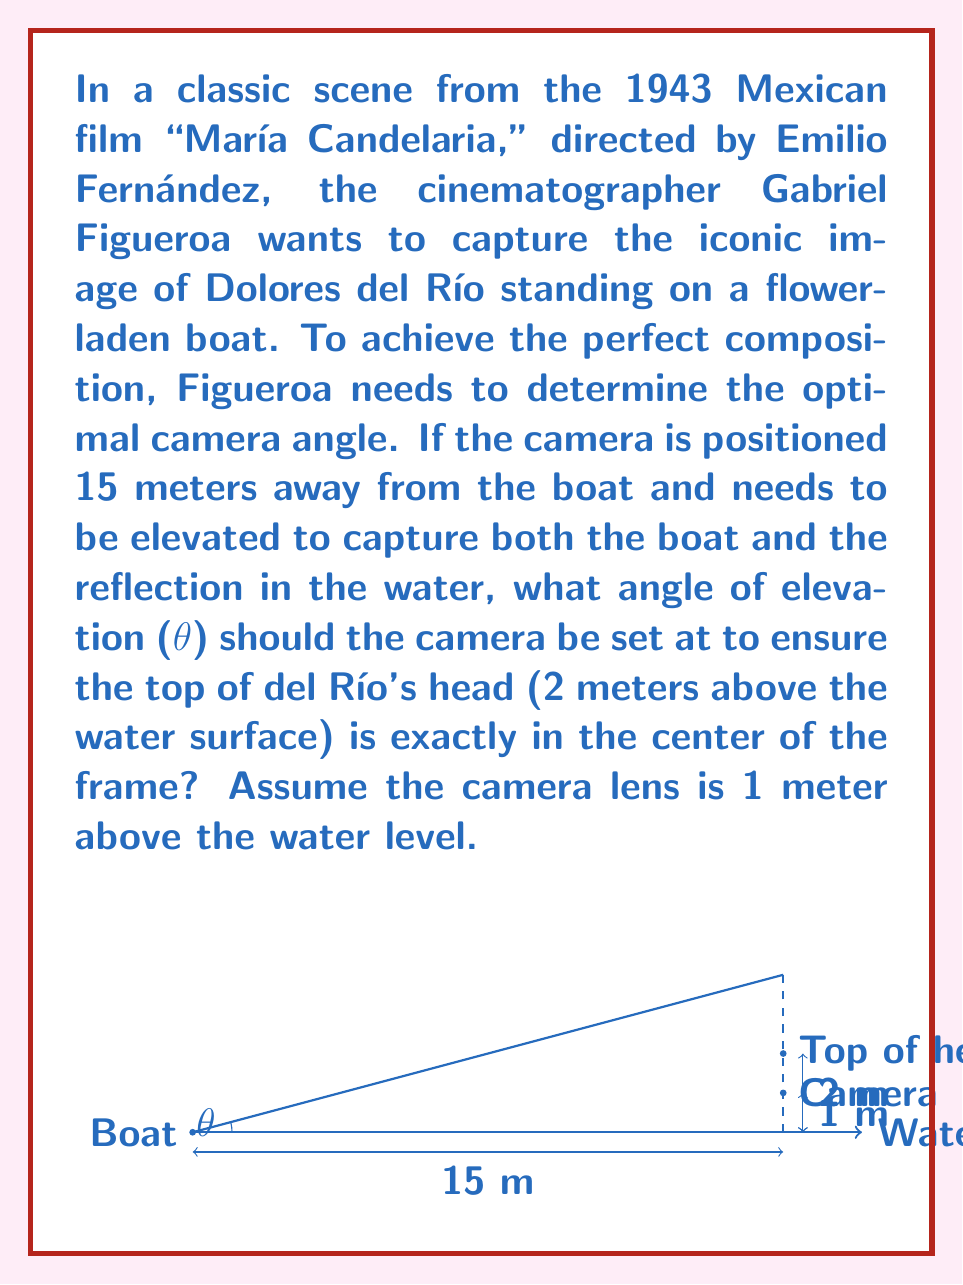Show me your answer to this math problem. Let's approach this step-by-step using trigonometry:

1) First, we need to identify the right triangle formed by the camera, the top of del Río's head, and the horizontal distance to the boat.

2) We know:
   - The adjacent side (horizontal distance) is 15 meters
   - The opposite side is the height difference between the camera and del Río's head: 2m - 1m = 1m

3) We're looking for the angle of elevation (θ), which can be found using the tangent function:

   $$\tan(\theta) = \frac{\text{opposite}}{\text{adjacent}}$$

4) Substituting our values:

   $$\tan(\theta) = \frac{1}{15}$$

5) To find θ, we need to use the inverse tangent (arctan or $\tan^{-1}$):

   $$\theta = \tan^{-1}(\frac{1}{15})$$

6) Using a calculator or trigonometric tables:

   $$\theta \approx 3.81^\circ$$

7) To ensure del Río's head is in the center of the frame, we need to aim the center of the lens at this angle.
Answer: $3.81^\circ$ 